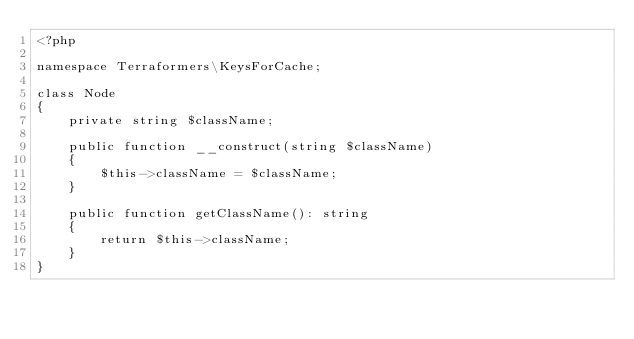Convert code to text. <code><loc_0><loc_0><loc_500><loc_500><_PHP_><?php

namespace Terraformers\KeysForCache;

class Node
{
    private string $className;

    public function __construct(string $className)
    {
        $this->className = $className;
    }

    public function getClassName(): string
    {
        return $this->className;
    }
}
</code> 